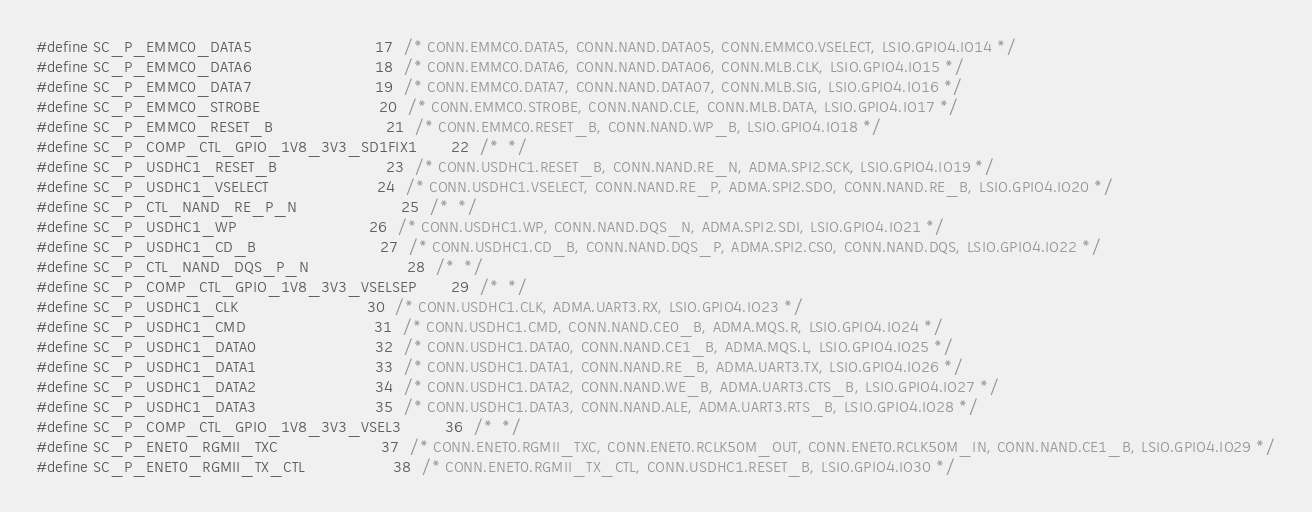<code> <loc_0><loc_0><loc_500><loc_500><_C_>#define SC_P_EMMC0_DATA5                         17	/* CONN.EMMC0.DATA5, CONN.NAND.DATA05, CONN.EMMC0.VSELECT, LSIO.GPIO4.IO14 */
#define SC_P_EMMC0_DATA6                         18	/* CONN.EMMC0.DATA6, CONN.NAND.DATA06, CONN.MLB.CLK, LSIO.GPIO4.IO15 */
#define SC_P_EMMC0_DATA7                         19	/* CONN.EMMC0.DATA7, CONN.NAND.DATA07, CONN.MLB.SIG, LSIO.GPIO4.IO16 */
#define SC_P_EMMC0_STROBE                        20	/* CONN.EMMC0.STROBE, CONN.NAND.CLE, CONN.MLB.DATA, LSIO.GPIO4.IO17 */
#define SC_P_EMMC0_RESET_B                       21	/* CONN.EMMC0.RESET_B, CONN.NAND.WP_B, LSIO.GPIO4.IO18 */
#define SC_P_COMP_CTL_GPIO_1V8_3V3_SD1FIX1       22	/*  */
#define SC_P_USDHC1_RESET_B                      23	/* CONN.USDHC1.RESET_B, CONN.NAND.RE_N, ADMA.SPI2.SCK, LSIO.GPIO4.IO19 */
#define SC_P_USDHC1_VSELECT                      24	/* CONN.USDHC1.VSELECT, CONN.NAND.RE_P, ADMA.SPI2.SDO, CONN.NAND.RE_B, LSIO.GPIO4.IO20 */
#define SC_P_CTL_NAND_RE_P_N                     25	/*  */
#define SC_P_USDHC1_WP                           26	/* CONN.USDHC1.WP, CONN.NAND.DQS_N, ADMA.SPI2.SDI, LSIO.GPIO4.IO21 */
#define SC_P_USDHC1_CD_B                         27	/* CONN.USDHC1.CD_B, CONN.NAND.DQS_P, ADMA.SPI2.CS0, CONN.NAND.DQS, LSIO.GPIO4.IO22 */
#define SC_P_CTL_NAND_DQS_P_N                    28	/*  */
#define SC_P_COMP_CTL_GPIO_1V8_3V3_VSELSEP       29	/*  */
#define SC_P_USDHC1_CLK                          30	/* CONN.USDHC1.CLK, ADMA.UART3.RX, LSIO.GPIO4.IO23 */
#define SC_P_USDHC1_CMD                          31	/* CONN.USDHC1.CMD, CONN.NAND.CE0_B, ADMA.MQS.R, LSIO.GPIO4.IO24 */
#define SC_P_USDHC1_DATA0                        32	/* CONN.USDHC1.DATA0, CONN.NAND.CE1_B, ADMA.MQS.L, LSIO.GPIO4.IO25 */
#define SC_P_USDHC1_DATA1                        33	/* CONN.USDHC1.DATA1, CONN.NAND.RE_B, ADMA.UART3.TX, LSIO.GPIO4.IO26 */
#define SC_P_USDHC1_DATA2                        34	/* CONN.USDHC1.DATA2, CONN.NAND.WE_B, ADMA.UART3.CTS_B, LSIO.GPIO4.IO27 */
#define SC_P_USDHC1_DATA3                        35	/* CONN.USDHC1.DATA3, CONN.NAND.ALE, ADMA.UART3.RTS_B, LSIO.GPIO4.IO28 */
#define SC_P_COMP_CTL_GPIO_1V8_3V3_VSEL3         36	/*  */
#define SC_P_ENET0_RGMII_TXC                     37	/* CONN.ENET0.RGMII_TXC, CONN.ENET0.RCLK50M_OUT, CONN.ENET0.RCLK50M_IN, CONN.NAND.CE1_B, LSIO.GPIO4.IO29 */
#define SC_P_ENET0_RGMII_TX_CTL                  38	/* CONN.ENET0.RGMII_TX_CTL, CONN.USDHC1.RESET_B, LSIO.GPIO4.IO30 */</code> 